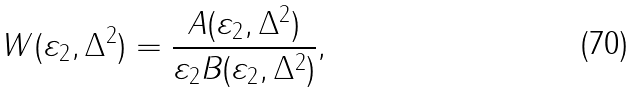Convert formula to latex. <formula><loc_0><loc_0><loc_500><loc_500>W ( \varepsilon _ { 2 } , \Delta ^ { 2 } ) = \frac { A ( \varepsilon _ { 2 } , \Delta ^ { 2 } ) } { \varepsilon _ { 2 } B ( \varepsilon _ { 2 } , \Delta ^ { 2 } ) } ,</formula> 